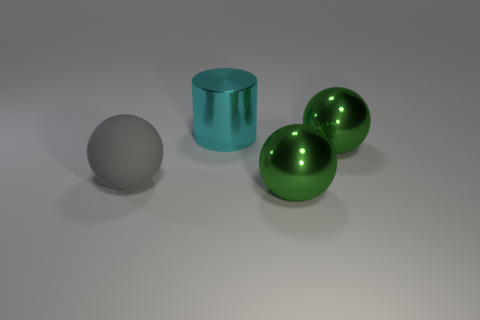Add 1 gray matte objects. How many objects exist? 5 Subtract all balls. How many objects are left? 1 Add 3 tiny purple things. How many tiny purple things exist? 3 Subtract 1 gray spheres. How many objects are left? 3 Subtract all gray objects. Subtract all tiny yellow shiny things. How many objects are left? 3 Add 1 large gray matte spheres. How many large gray matte spheres are left? 2 